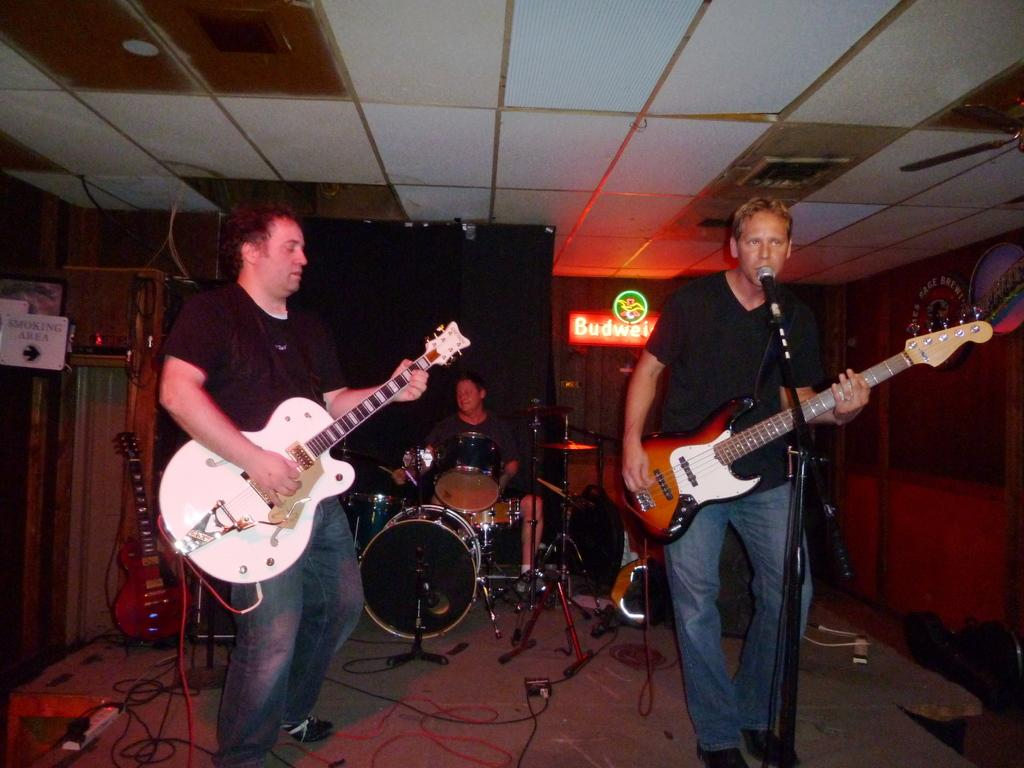What are the two guys in the image doing? The two guys in the image are playing guitars. What is the guy on the right side doing? The guy on the right side is singing. How is the singer holding the microphone? There is a microphone present in front of the singer. What instrument is the person in the middle playing? The person in the middle is playing the drums. What type of jewel is the singer wearing on their head in the image? There is no jewel visible on the singer's head in the image. How many seats are available for the audience in the image? The image does not show any seats for an audience, as it focuses on the musicians. 